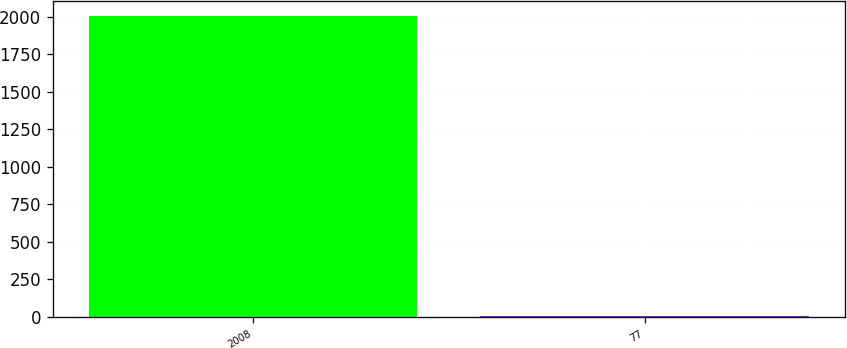Convert chart to OTSL. <chart><loc_0><loc_0><loc_500><loc_500><bar_chart><fcel>2008<fcel>77<nl><fcel>2007<fcel>7.4<nl></chart> 